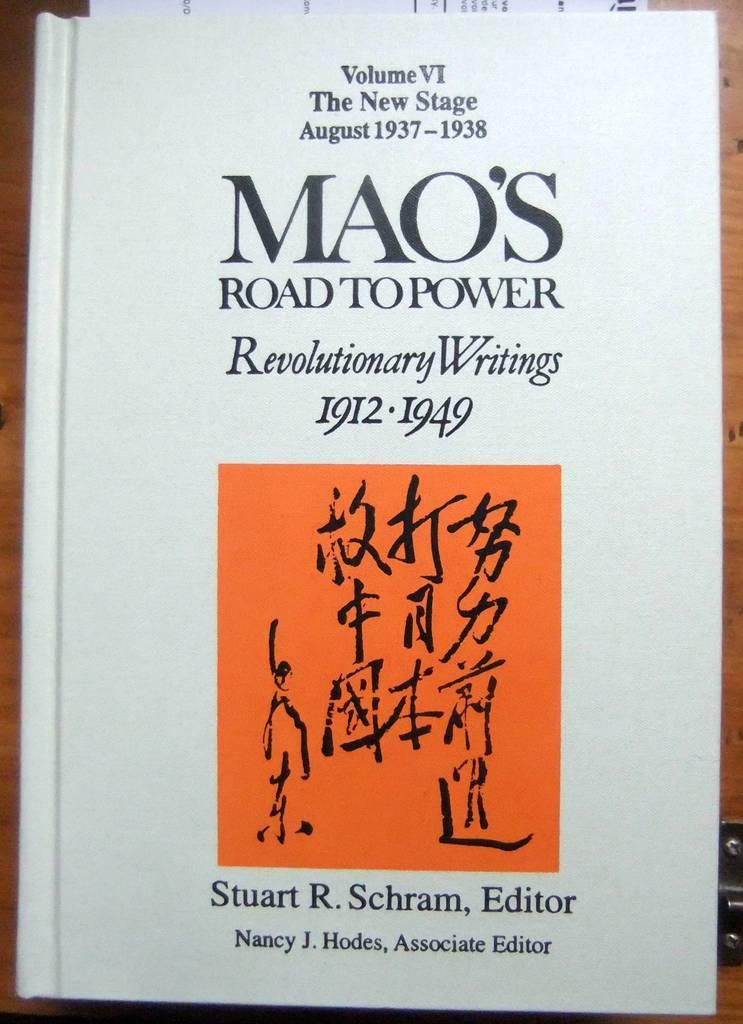Provide a one-sentence caption for the provided image. The cover of the book Mao's Road to Power, Revolutionary Writings 1912-1949. 